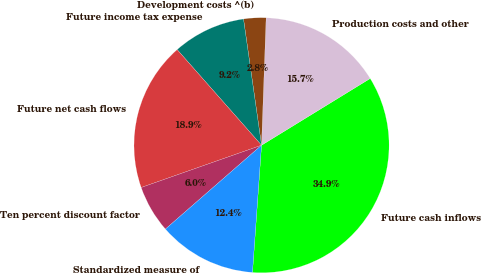<chart> <loc_0><loc_0><loc_500><loc_500><pie_chart><fcel>Future cash inflows<fcel>Production costs and other<fcel>Development costs ^(b)<fcel>Future income tax expense<fcel>Future net cash flows<fcel>Ten percent discount factor<fcel>Standardized measure of<nl><fcel>34.9%<fcel>15.66%<fcel>2.83%<fcel>9.25%<fcel>18.87%<fcel>6.04%<fcel>12.45%<nl></chart> 